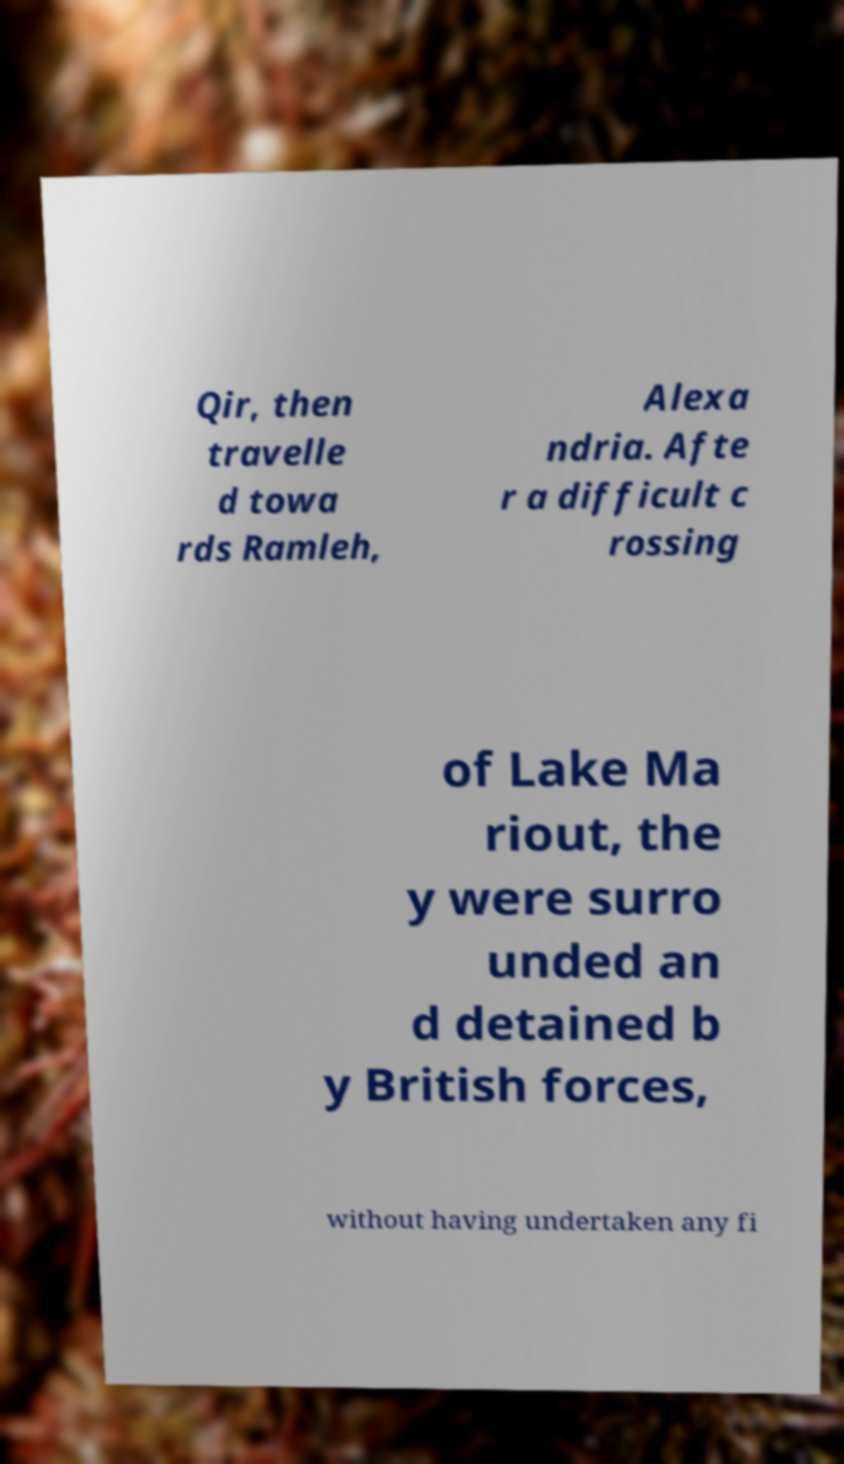Could you assist in decoding the text presented in this image and type it out clearly? Qir, then travelle d towa rds Ramleh, Alexa ndria. Afte r a difficult c rossing of Lake Ma riout, the y were surro unded an d detained b y British forces, without having undertaken any fi 